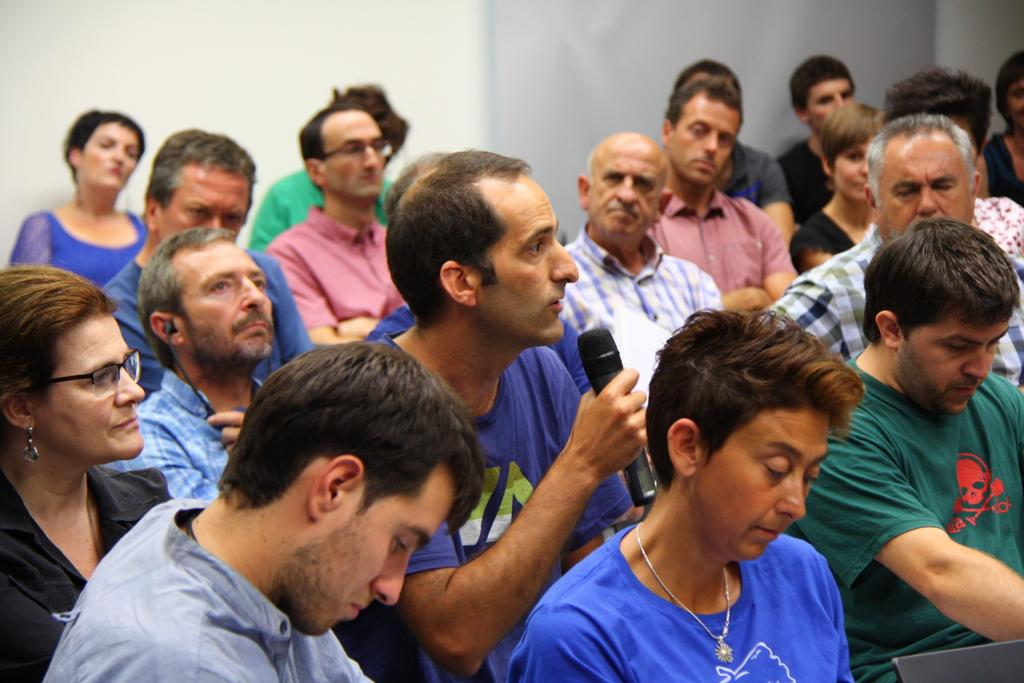What are the people in the image doing? The people in the image are sitting. What is one person holding in his hand? One person is holding a mic in his hand. What is the person holding the mic doing? The person holding the mic is speaking. What type of suit is the person wearing while speaking in the image? There is no information about the person's clothing in the image, so we cannot determine if they are wearing a suit or not. 